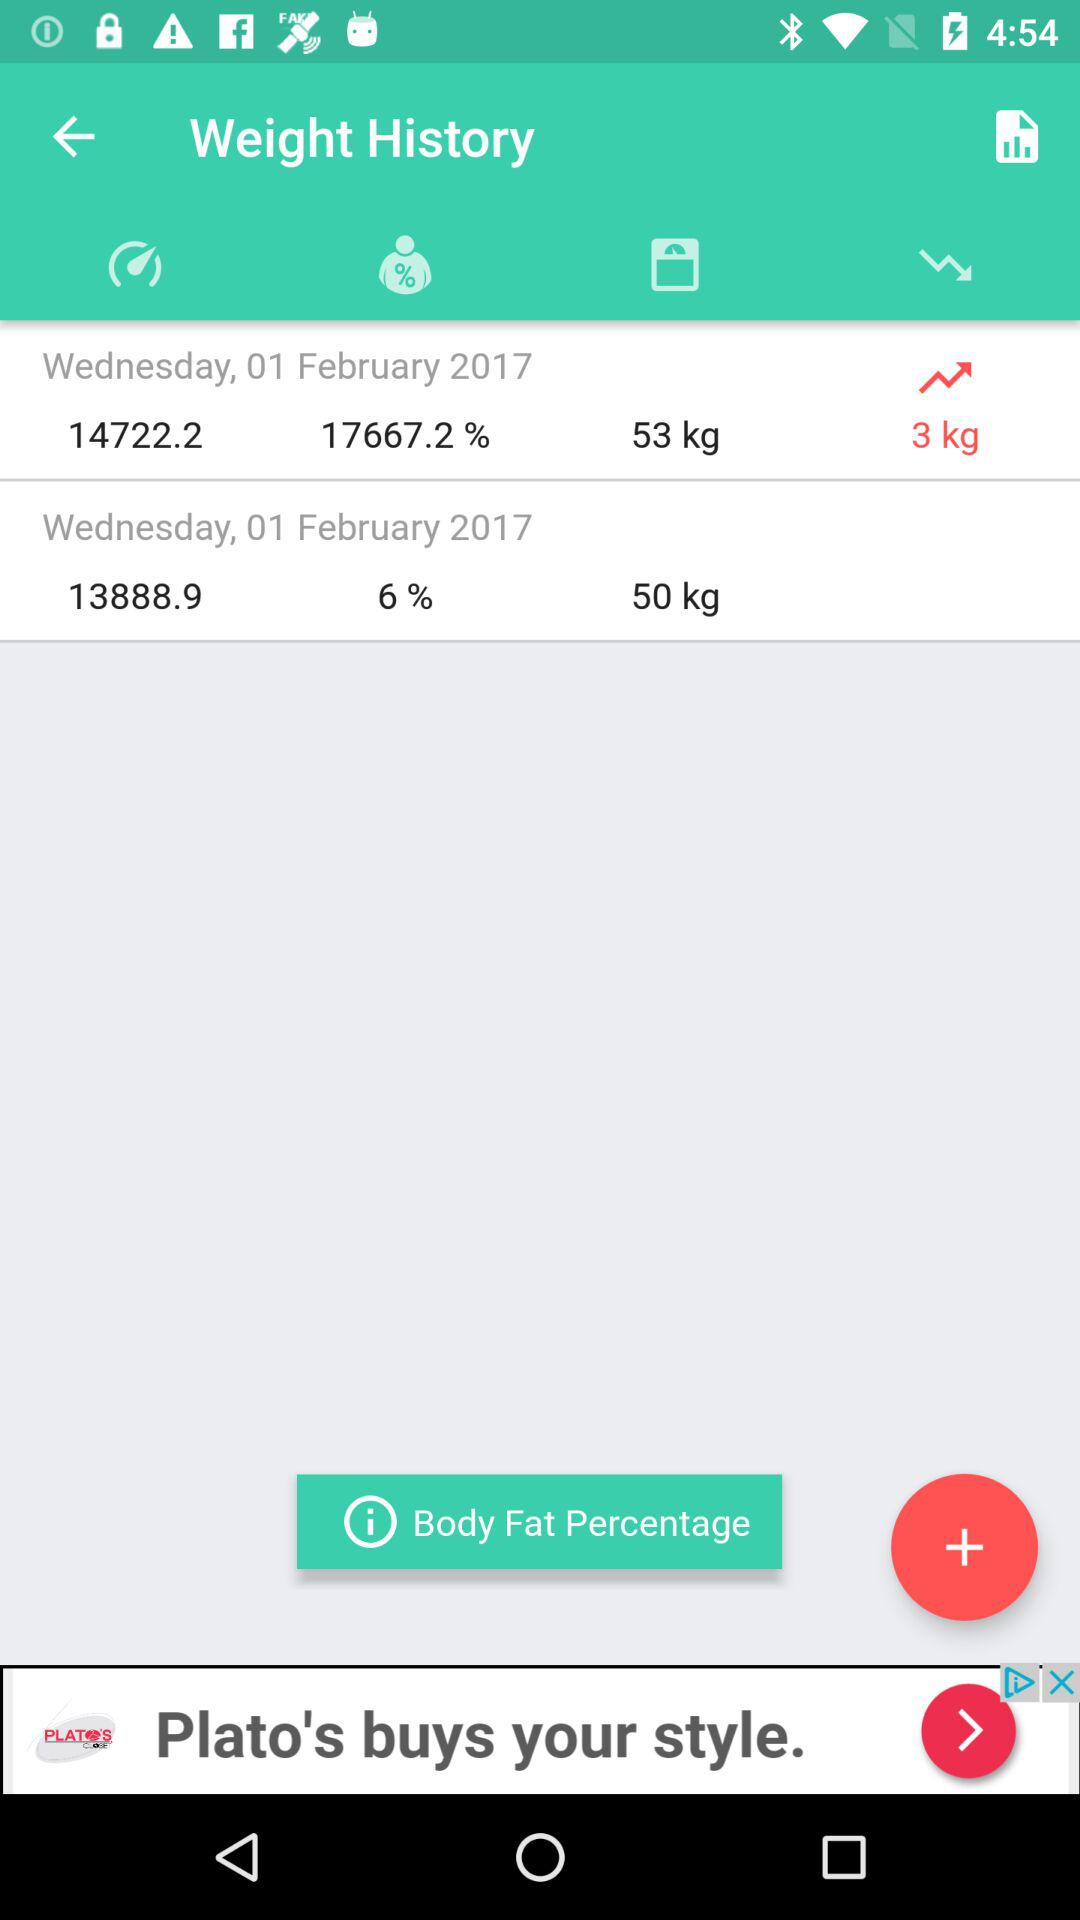What is the weight on 1 February 2017? The weights on 1 February 2017 are 5o kg and 53 kg. 